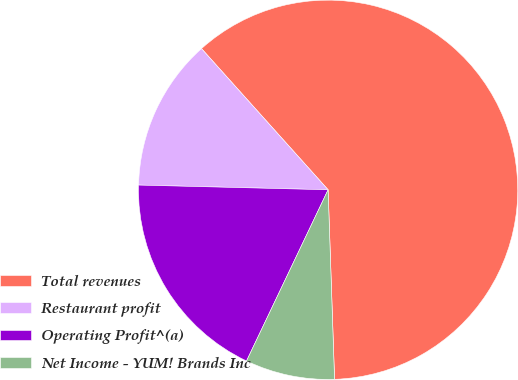Convert chart. <chart><loc_0><loc_0><loc_500><loc_500><pie_chart><fcel>Total revenues<fcel>Restaurant profit<fcel>Operating Profit^(a)<fcel>Net Income - YUM! Brands Inc<nl><fcel>61.1%<fcel>12.97%<fcel>18.32%<fcel>7.62%<nl></chart> 